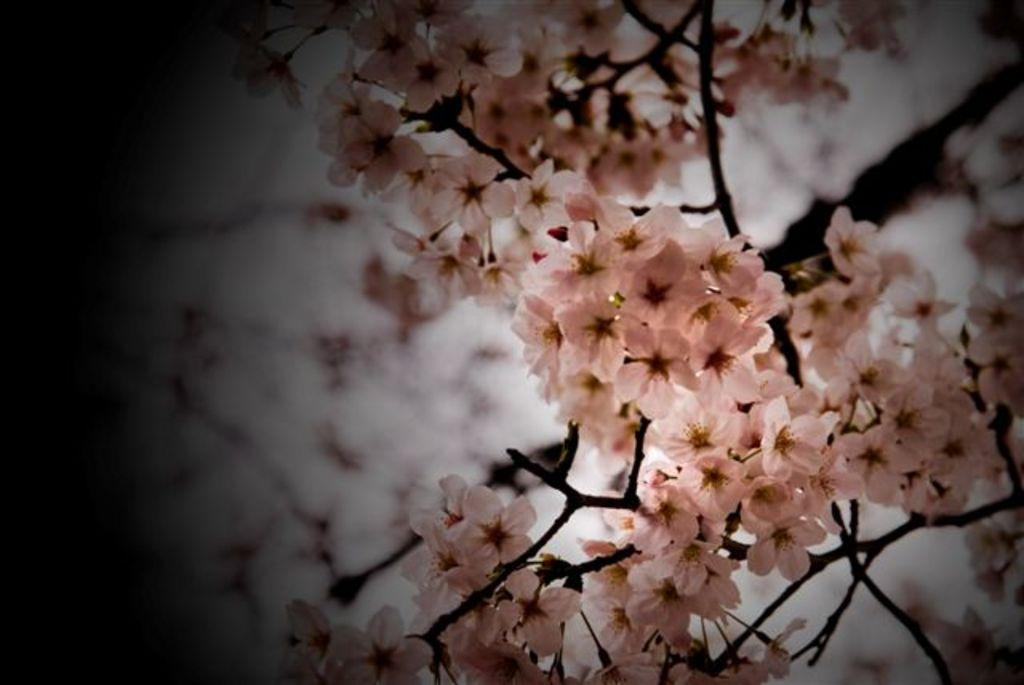What type of living organisms can be seen in the image? There are flowers in the image. To which plant do the flowers belong? The flowers belong to a plant. What policy is the governor discussing with the flowers in the image? There is no governor or policy discussion present in the image; it only features flowers and a plant. 